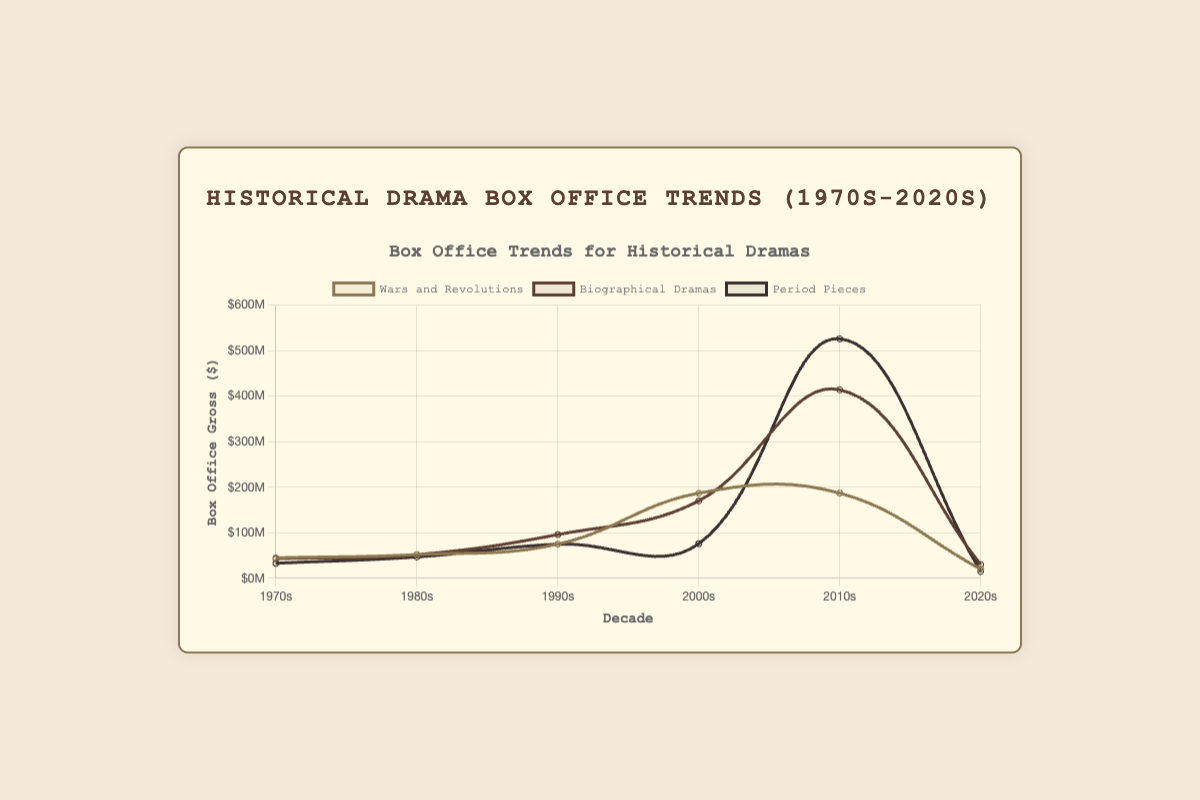What is the overall trend for the box office gross of "Wars and Revolutions" films over the decades? The box office gross of "Wars and Revolutions" films shows an upward trend from the 1970s to the 2010s, reaching a peak in the 2010s, and then sharply declining in the 2020s.
Answer: Upward trend, peak in 2010s, sharp decline in 2020s Which decade had the highest box office gross for "Biographical Dramas"? By looking at the line representing "Biographical Dramas," it peaked in the 2010s, indicating the highest box office gross.
Answer: 2010s How did the "Period Pieces" films' box office gross change from the 1980s to the 2010s? The line representing "Period Pieces" shows a gradual increase from the 1980s, peaking sharply in the 2010s, indicating a significant rise in the box office gross over these decades.
Answer: Increased, peaked in 2010s Compare the box office gross of "Biographical Dramas" and "Wars and Revolutions" films in the 2000s. Which one was higher? In the 2000s, the line for "Biographical Dramas" is lower than "Wars and Revolutions," indicating that "Wars and Revolutions" films had a higher box office gross.
Answer: Wars and Revolutions Which sub-category showed the most dramatic decline in box office gross from the 2010s to the 2020s? By comparing the lines from the 2010s to the 2020s, "Period Pieces" showed the most dramatic decline.
Answer: Period Pieces What was the average box office gross for "Period Pieces" films in the 1990s and 2000s? The box office gross for "Period Pieces" in the 1990s is $75,000,000 and for the 2000s is $76,000,000. The average is ($75,000,000 + $76,000,000)/2.
Answer: $75.5M Which decade saw equal box office gross for "Wars and Revolutions" and "Biographical Dramas"? The gross for "Wars and Revolutions" and "Biographical Dramas" was equal in the 1980s, as shown by the intersecting lines at that decade.
Answer: 1980s How much higher was the box office gross for "Biographical Dramas" compared to "Period Pieces" in the 2010s? "Biographical Dramas" grossed $414,000,000, and "Period Pieces" grossed $526,000,000. $526M - $414M = $112M.
Answer: $112M higher Which sub-category had the most stable box office gross over the decades? "Biographical Dramas" showed relatively stable box office performance without dramatic fluctuations observed in the visual lines.
Answer: Biographical Dramas Did the box office gross for "Period Pieces" ever surpass $500,000,000? Which decade? As shown in the figure, "Period Pieces" surpassed $500,000,000 in the 2010s.
Answer: Yes, 2010s 